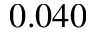Convert formula to latex. <formula><loc_0><loc_0><loc_500><loc_500>0 . 0 4 0</formula> 